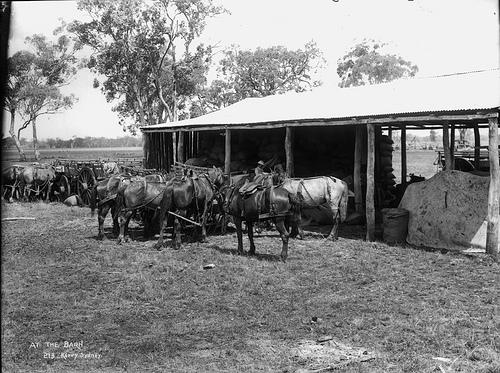Where is a saddle?
Keep it brief. On horse. What animal is pictured?
Give a very brief answer. Horse. How many horses are in this photograph?
Concise answer only. 7. What color is the roof?
Answer briefly. White. How many horses are there?
Be succinct. 6. What are these horses used for?
Give a very brief answer. Riding. 